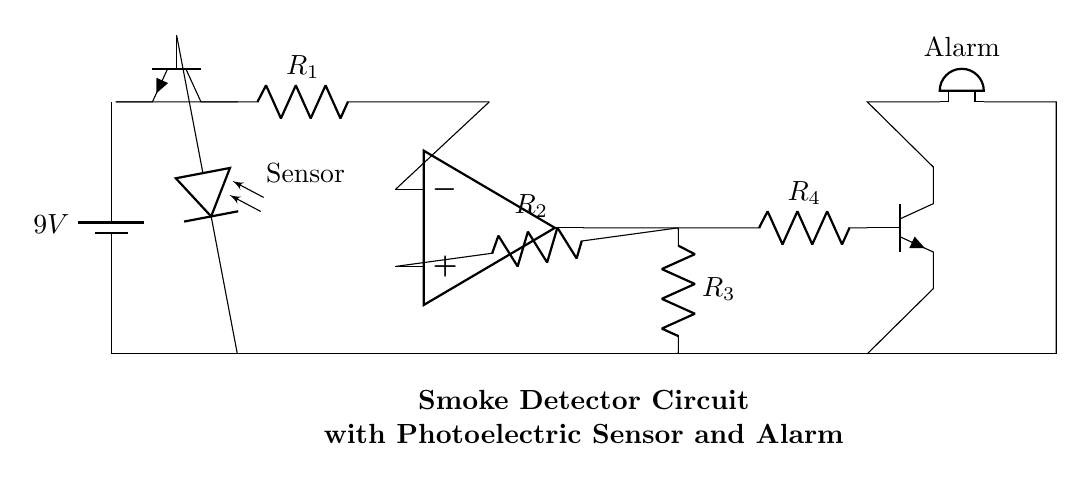What is the voltage supplied by the battery? The voltage is specified directly by the battery component in the diagram, which indicates a voltage of 9 volts.
Answer: 9 volts What type of sensor is used in this circuit? The circuit diagram labels a component as a "Sensor," and since it is connected to a photoelectric device, it indicates the use of a photoelectric sensor.
Answer: Photoelectric sensor How many resistors are present in the circuit? By counting the resistor symbols in the diagram, there are a total of four distinct resistors labeled as R1, R2, R3, and R4, confirmed by their designations.
Answer: Four What is the main function of the op-amp in this circuit? The operational amplifier is part of a comparator setup, which compares the input signal from the sensor against a reference voltage, thus determining whether to activate the alarm.
Answer: Comparator What is directly connected to the output of the operational amplifier? Following the path from the op-amp output in the diagram, it leads to a resistor and subsequently connects to a transistor, indicating the control circuitry for the alarm activation.
Answer: Resistor What component is responsible for sound output in this circuit? The component labeled as "Alarm" is a buzzer in the circuit, which is directly responsible for producing sound when the alarm is triggered.
Answer: Buzzer 